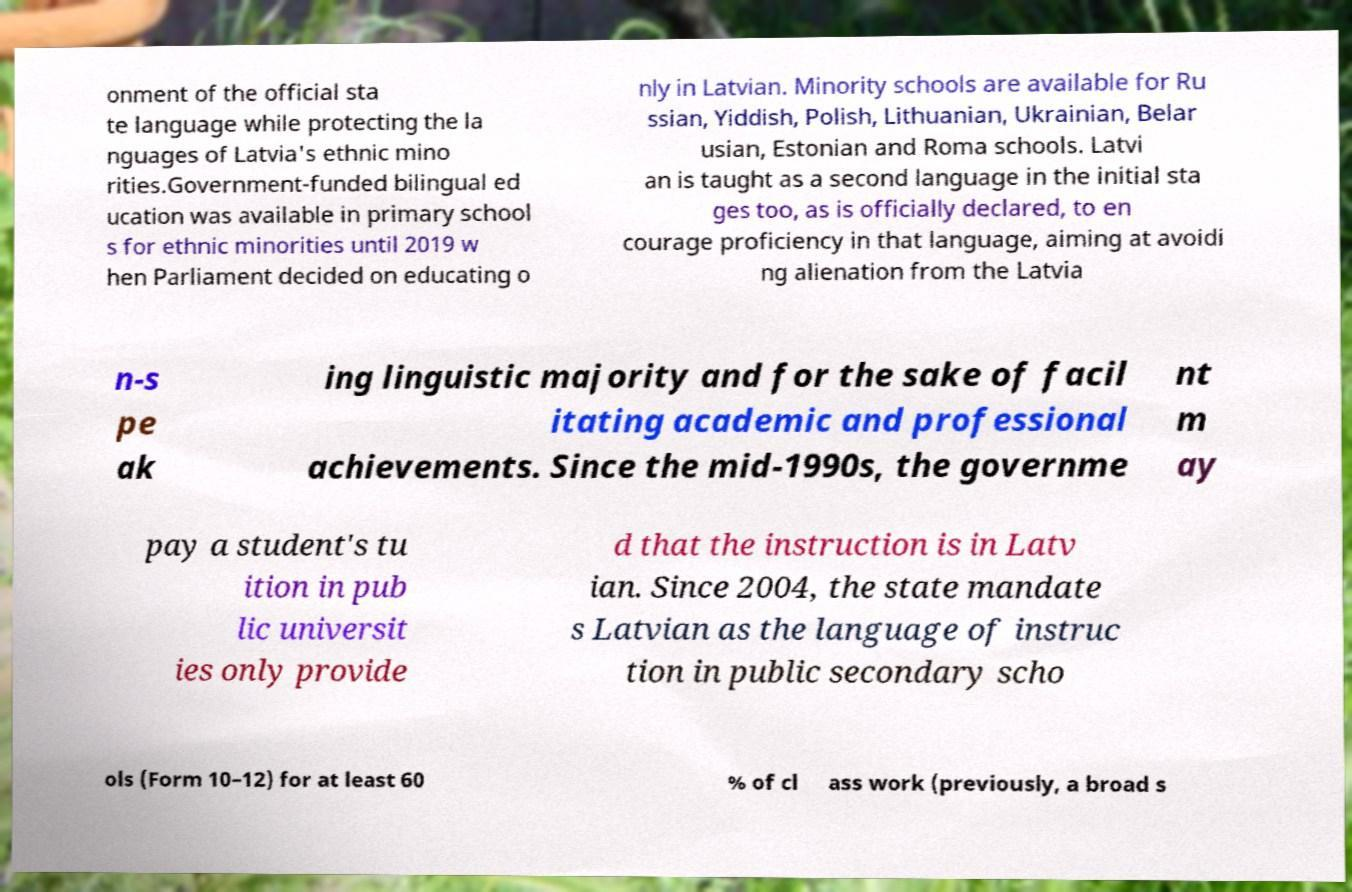Please identify and transcribe the text found in this image. onment of the official sta te language while protecting the la nguages of Latvia's ethnic mino rities.Government-funded bilingual ed ucation was available in primary school s for ethnic minorities until 2019 w hen Parliament decided on educating o nly in Latvian. Minority schools are available for Ru ssian, Yiddish, Polish, Lithuanian, Ukrainian, Belar usian, Estonian and Roma schools. Latvi an is taught as a second language in the initial sta ges too, as is officially declared, to en courage proficiency in that language, aiming at avoidi ng alienation from the Latvia n-s pe ak ing linguistic majority and for the sake of facil itating academic and professional achievements. Since the mid-1990s, the governme nt m ay pay a student's tu ition in pub lic universit ies only provide d that the instruction is in Latv ian. Since 2004, the state mandate s Latvian as the language of instruc tion in public secondary scho ols (Form 10–12) for at least 60 % of cl ass work (previously, a broad s 